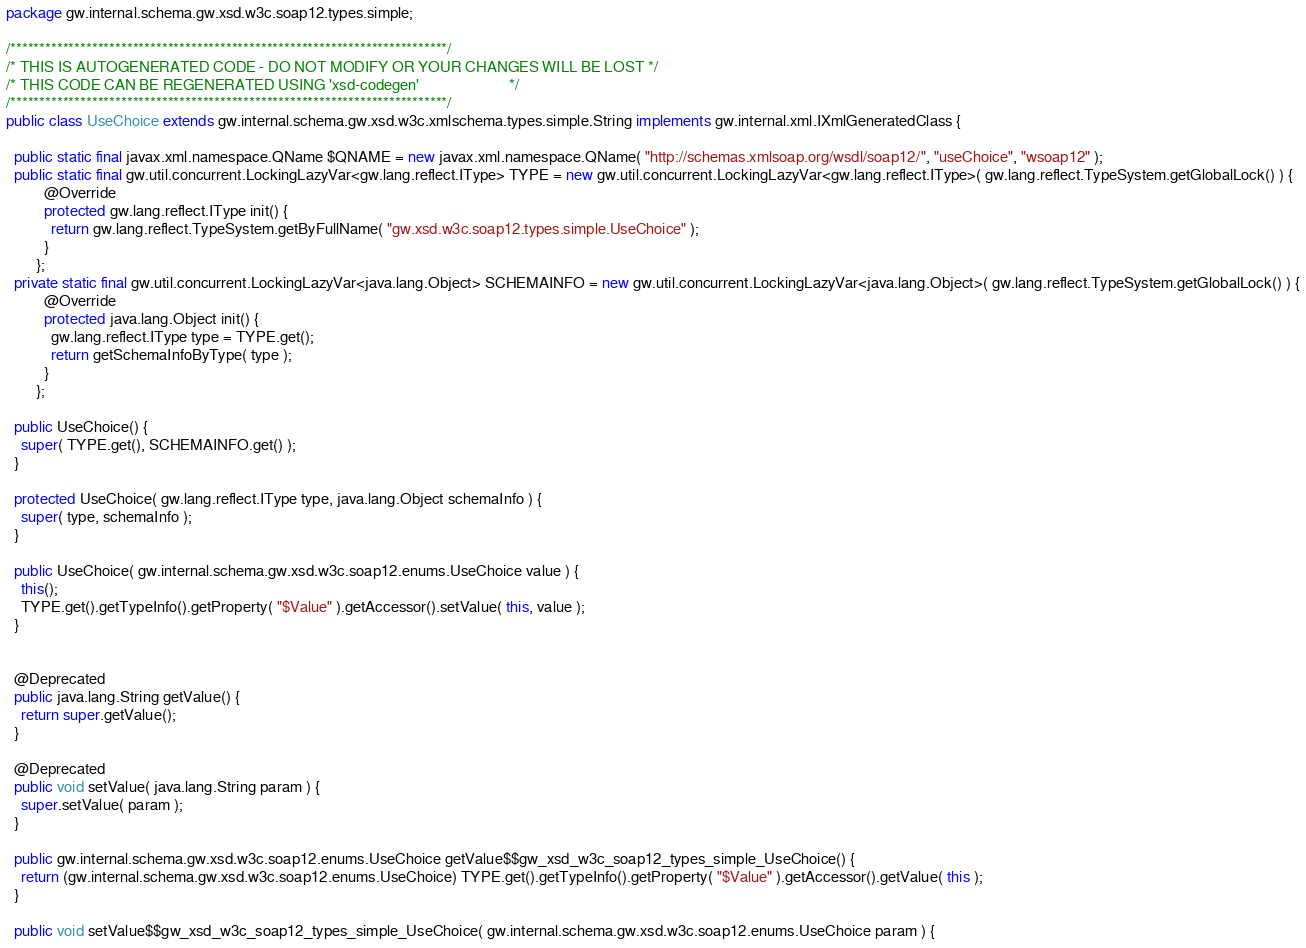Convert code to text. <code><loc_0><loc_0><loc_500><loc_500><_Java_>package gw.internal.schema.gw.xsd.w3c.soap12.types.simple;

/***************************************************************************/
/* THIS IS AUTOGENERATED CODE - DO NOT MODIFY OR YOUR CHANGES WILL BE LOST */
/* THIS CODE CAN BE REGENERATED USING 'xsd-codegen'                        */
/***************************************************************************/
public class UseChoice extends gw.internal.schema.gw.xsd.w3c.xmlschema.types.simple.String implements gw.internal.xml.IXmlGeneratedClass {

  public static final javax.xml.namespace.QName $QNAME = new javax.xml.namespace.QName( "http://schemas.xmlsoap.org/wsdl/soap12/", "useChoice", "wsoap12" );
  public static final gw.util.concurrent.LockingLazyVar<gw.lang.reflect.IType> TYPE = new gw.util.concurrent.LockingLazyVar<gw.lang.reflect.IType>( gw.lang.reflect.TypeSystem.getGlobalLock() ) {
          @Override
          protected gw.lang.reflect.IType init() {
            return gw.lang.reflect.TypeSystem.getByFullName( "gw.xsd.w3c.soap12.types.simple.UseChoice" );
          }
        };
  private static final gw.util.concurrent.LockingLazyVar<java.lang.Object> SCHEMAINFO = new gw.util.concurrent.LockingLazyVar<java.lang.Object>( gw.lang.reflect.TypeSystem.getGlobalLock() ) {
          @Override
          protected java.lang.Object init() {
            gw.lang.reflect.IType type = TYPE.get();
            return getSchemaInfoByType( type );
          }
        };

  public UseChoice() {
    super( TYPE.get(), SCHEMAINFO.get() );
  }

  protected UseChoice( gw.lang.reflect.IType type, java.lang.Object schemaInfo ) {
    super( type, schemaInfo );
  }

  public UseChoice( gw.internal.schema.gw.xsd.w3c.soap12.enums.UseChoice value ) {
    this();
    TYPE.get().getTypeInfo().getProperty( "$Value" ).getAccessor().setValue( this, value );
  }


  @Deprecated
  public java.lang.String getValue() {
    return super.getValue();
  }

  @Deprecated
  public void setValue( java.lang.String param ) {
    super.setValue( param );
  }

  public gw.internal.schema.gw.xsd.w3c.soap12.enums.UseChoice getValue$$gw_xsd_w3c_soap12_types_simple_UseChoice() {
    return (gw.internal.schema.gw.xsd.w3c.soap12.enums.UseChoice) TYPE.get().getTypeInfo().getProperty( "$Value" ).getAccessor().getValue( this );
  }

  public void setValue$$gw_xsd_w3c_soap12_types_simple_UseChoice( gw.internal.schema.gw.xsd.w3c.soap12.enums.UseChoice param ) {</code> 